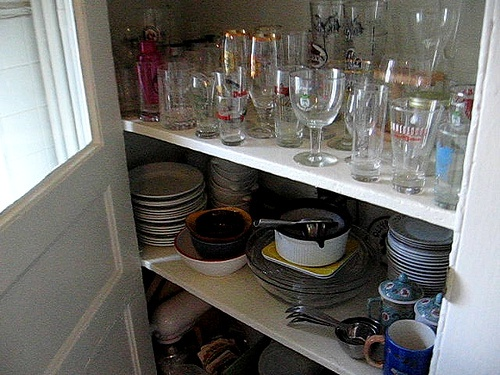Describe the objects in this image and their specific colors. I can see cup in darkgray, gray, and lightgray tones, bowl in darkgray, black, and gray tones, cup in darkgray, gray, and lightgray tones, wine glass in darkgray, gray, and lightgray tones, and cup in darkgray, black, navy, and gray tones in this image. 